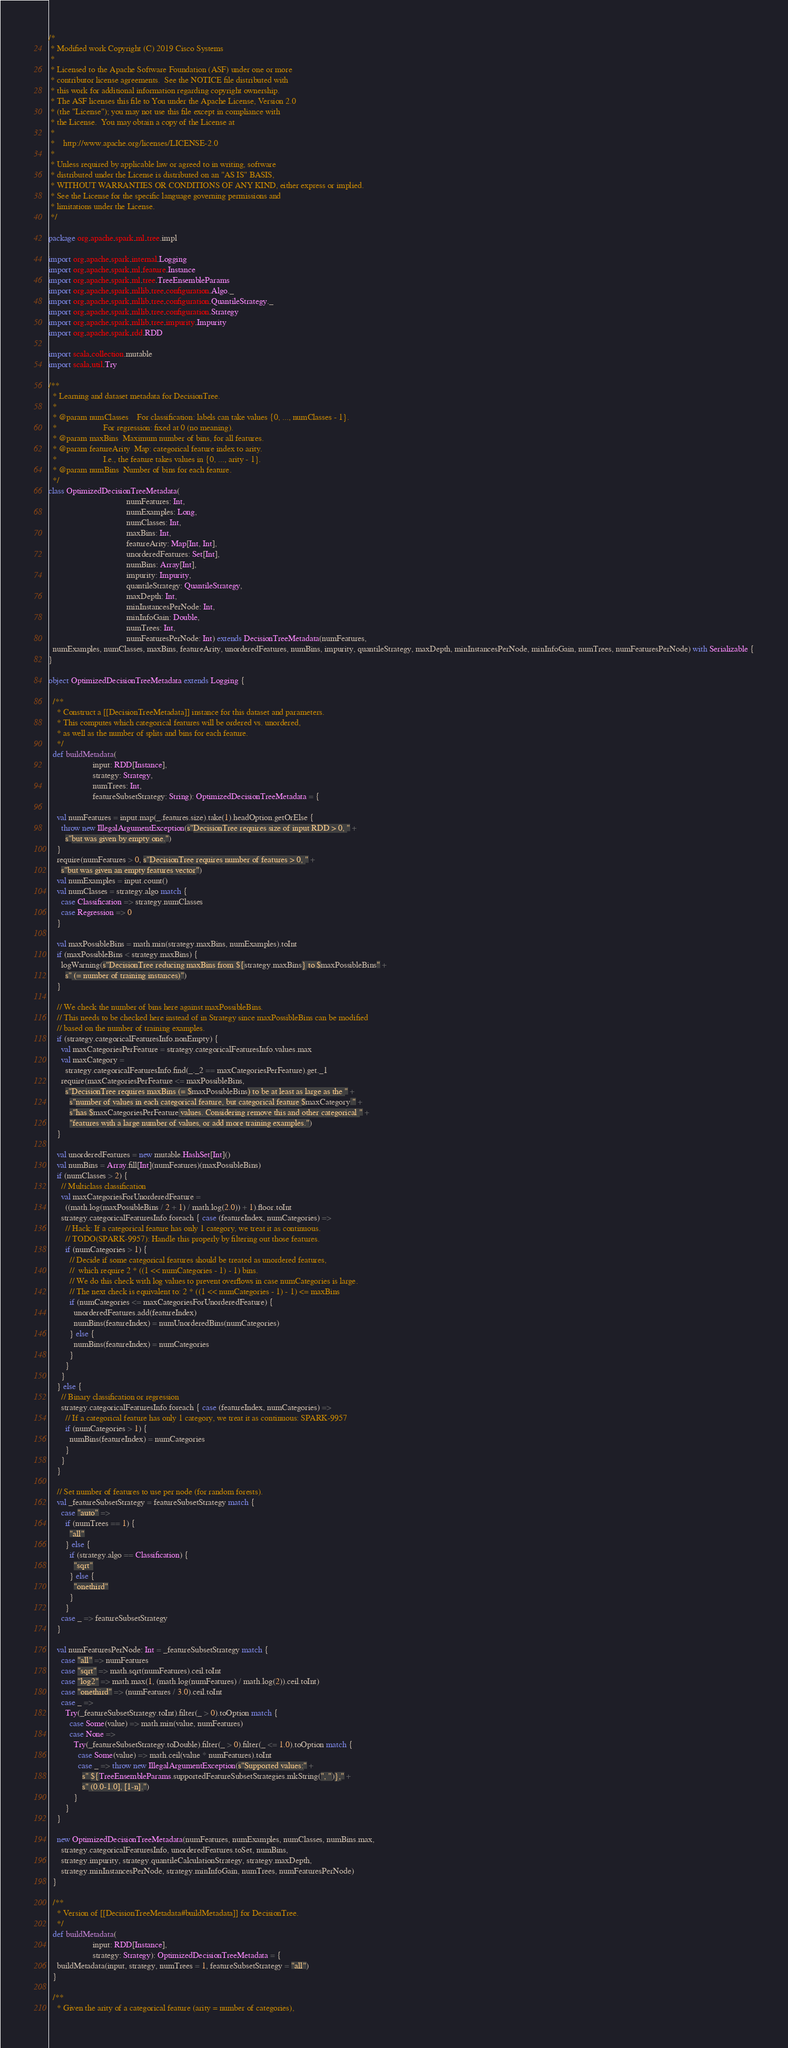<code> <loc_0><loc_0><loc_500><loc_500><_Scala_>/*
 * Modified work Copyright (C) 2019 Cisco Systems
 *
 * Licensed to the Apache Software Foundation (ASF) under one or more
 * contributor license agreements.  See the NOTICE file distributed with
 * this work for additional information regarding copyright ownership.
 * The ASF licenses this file to You under the Apache License, Version 2.0
 * (the "License"); you may not use this file except in compliance with
 * the License.  You may obtain a copy of the License at
 *
 *    http://www.apache.org/licenses/LICENSE-2.0
 *
 * Unless required by applicable law or agreed to in writing, software
 * distributed under the License is distributed on an "AS IS" BASIS,
 * WITHOUT WARRANTIES OR CONDITIONS OF ANY KIND, either express or implied.
 * See the License for the specific language governing permissions and
 * limitations under the License.
 */

package org.apache.spark.ml.tree.impl

import org.apache.spark.internal.Logging
import org.apache.spark.ml.feature.Instance
import org.apache.spark.ml.tree.TreeEnsembleParams
import org.apache.spark.mllib.tree.configuration.Algo._
import org.apache.spark.mllib.tree.configuration.QuantileStrategy._
import org.apache.spark.mllib.tree.configuration.Strategy
import org.apache.spark.mllib.tree.impurity.Impurity
import org.apache.spark.rdd.RDD

import scala.collection.mutable
import scala.util.Try

/**
  * Learning and dataset metadata for DecisionTree.
  *
  * @param numClasses    For classification: labels can take values {0, ..., numClasses - 1}.
  *                      For regression: fixed at 0 (no meaning).
  * @param maxBins  Maximum number of bins, for all features.
  * @param featureArity  Map: categorical feature index to arity.
  *                      I.e., the feature takes values in {0, ..., arity - 1}.
  * @param numBins  Number of bins for each feature.
  */
class OptimizedDecisionTreeMetadata(
                                     numFeatures: Int,
                                     numExamples: Long,
                                     numClasses: Int,
                                     maxBins: Int,
                                     featureArity: Map[Int, Int],
                                     unorderedFeatures: Set[Int],
                                     numBins: Array[Int],
                                     impurity: Impurity,
                                     quantileStrategy: QuantileStrategy,
                                     maxDepth: Int,
                                     minInstancesPerNode: Int,
                                     minInfoGain: Double,
                                     numTrees: Int,
                                     numFeaturesPerNode: Int) extends DecisionTreeMetadata(numFeatures,
  numExamples, numClasses, maxBins, featureArity, unorderedFeatures, numBins, impurity, quantileStrategy, maxDepth, minInstancesPerNode, minInfoGain, numTrees, numFeaturesPerNode) with Serializable {
}

object OptimizedDecisionTreeMetadata extends Logging {

  /**
    * Construct a [[DecisionTreeMetadata]] instance for this dataset and parameters.
    * This computes which categorical features will be ordered vs. unordered,
    * as well as the number of splits and bins for each feature.
    */
  def buildMetadata(
                     input: RDD[Instance],
                     strategy: Strategy,
                     numTrees: Int,
                     featureSubsetStrategy: String): OptimizedDecisionTreeMetadata = {

    val numFeatures = input.map(_.features.size).take(1).headOption.getOrElse {
      throw new IllegalArgumentException(s"DecisionTree requires size of input RDD > 0, " +
        s"but was given by empty one.")
    }
    require(numFeatures > 0, s"DecisionTree requires number of features > 0, " +
      s"but was given an empty features vector")
    val numExamples = input.count()
    val numClasses = strategy.algo match {
      case Classification => strategy.numClasses
      case Regression => 0
    }

    val maxPossibleBins = math.min(strategy.maxBins, numExamples).toInt
    if (maxPossibleBins < strategy.maxBins) {
      logWarning(s"DecisionTree reducing maxBins from ${strategy.maxBins} to $maxPossibleBins" +
        s" (= number of training instances)")
    }

    // We check the number of bins here against maxPossibleBins.
    // This needs to be checked here instead of in Strategy since maxPossibleBins can be modified
    // based on the number of training examples.
    if (strategy.categoricalFeaturesInfo.nonEmpty) {
      val maxCategoriesPerFeature = strategy.categoricalFeaturesInfo.values.max
      val maxCategory =
        strategy.categoricalFeaturesInfo.find(_._2 == maxCategoriesPerFeature).get._1
      require(maxCategoriesPerFeature <= maxPossibleBins,
        s"DecisionTree requires maxBins (= $maxPossibleBins) to be at least as large as the " +
          s"number of values in each categorical feature, but categorical feature $maxCategory " +
          s"has $maxCategoriesPerFeature values. Considering remove this and other categorical " +
          "features with a large number of values, or add more training examples.")
    }

    val unorderedFeatures = new mutable.HashSet[Int]()
    val numBins = Array.fill[Int](numFeatures)(maxPossibleBins)
    if (numClasses > 2) {
      // Multiclass classification
      val maxCategoriesForUnorderedFeature =
        ((math.log(maxPossibleBins / 2 + 1) / math.log(2.0)) + 1).floor.toInt
      strategy.categoricalFeaturesInfo.foreach { case (featureIndex, numCategories) =>
        // Hack: If a categorical feature has only 1 category, we treat it as continuous.
        // TODO(SPARK-9957): Handle this properly by filtering out those features.
        if (numCategories > 1) {
          // Decide if some categorical features should be treated as unordered features,
          //  which require 2 * ((1 << numCategories - 1) - 1) bins.
          // We do this check with log values to prevent overflows in case numCategories is large.
          // The next check is equivalent to: 2 * ((1 << numCategories - 1) - 1) <= maxBins
          if (numCategories <= maxCategoriesForUnorderedFeature) {
            unorderedFeatures.add(featureIndex)
            numBins(featureIndex) = numUnorderedBins(numCategories)
          } else {
            numBins(featureIndex) = numCategories
          }
        }
      }
    } else {
      // Binary classification or regression
      strategy.categoricalFeaturesInfo.foreach { case (featureIndex, numCategories) =>
        // If a categorical feature has only 1 category, we treat it as continuous: SPARK-9957
        if (numCategories > 1) {
          numBins(featureIndex) = numCategories
        }
      }
    }

    // Set number of features to use per node (for random forests).
    val _featureSubsetStrategy = featureSubsetStrategy match {
      case "auto" =>
        if (numTrees == 1) {
          "all"
        } else {
          if (strategy.algo == Classification) {
            "sqrt"
          } else {
            "onethird"
          }
        }
      case _ => featureSubsetStrategy
    }

    val numFeaturesPerNode: Int = _featureSubsetStrategy match {
      case "all" => numFeatures
      case "sqrt" => math.sqrt(numFeatures).ceil.toInt
      case "log2" => math.max(1, (math.log(numFeatures) / math.log(2)).ceil.toInt)
      case "onethird" => (numFeatures / 3.0).ceil.toInt
      case _ =>
        Try(_featureSubsetStrategy.toInt).filter(_ > 0).toOption match {
          case Some(value) => math.min(value, numFeatures)
          case None =>
            Try(_featureSubsetStrategy.toDouble).filter(_ > 0).filter(_ <= 1.0).toOption match {
              case Some(value) => math.ceil(value * numFeatures).toInt
              case _ => throw new IllegalArgumentException(s"Supported values:" +
                s" ${TreeEnsembleParams.supportedFeatureSubsetStrategies.mkString(", ")}," +
                s" (0.0-1.0], [1-n].")
            }
        }
    }

    new OptimizedDecisionTreeMetadata(numFeatures, numExamples, numClasses, numBins.max,
      strategy.categoricalFeaturesInfo, unorderedFeatures.toSet, numBins,
      strategy.impurity, strategy.quantileCalculationStrategy, strategy.maxDepth,
      strategy.minInstancesPerNode, strategy.minInfoGain, numTrees, numFeaturesPerNode)
  }

  /**
    * Version of [[DecisionTreeMetadata#buildMetadata]] for DecisionTree.
    */
  def buildMetadata(
                     input: RDD[Instance],
                     strategy: Strategy): OptimizedDecisionTreeMetadata = {
    buildMetadata(input, strategy, numTrees = 1, featureSubsetStrategy = "all")
  }

  /**
    * Given the arity of a categorical feature (arity = number of categories),</code> 